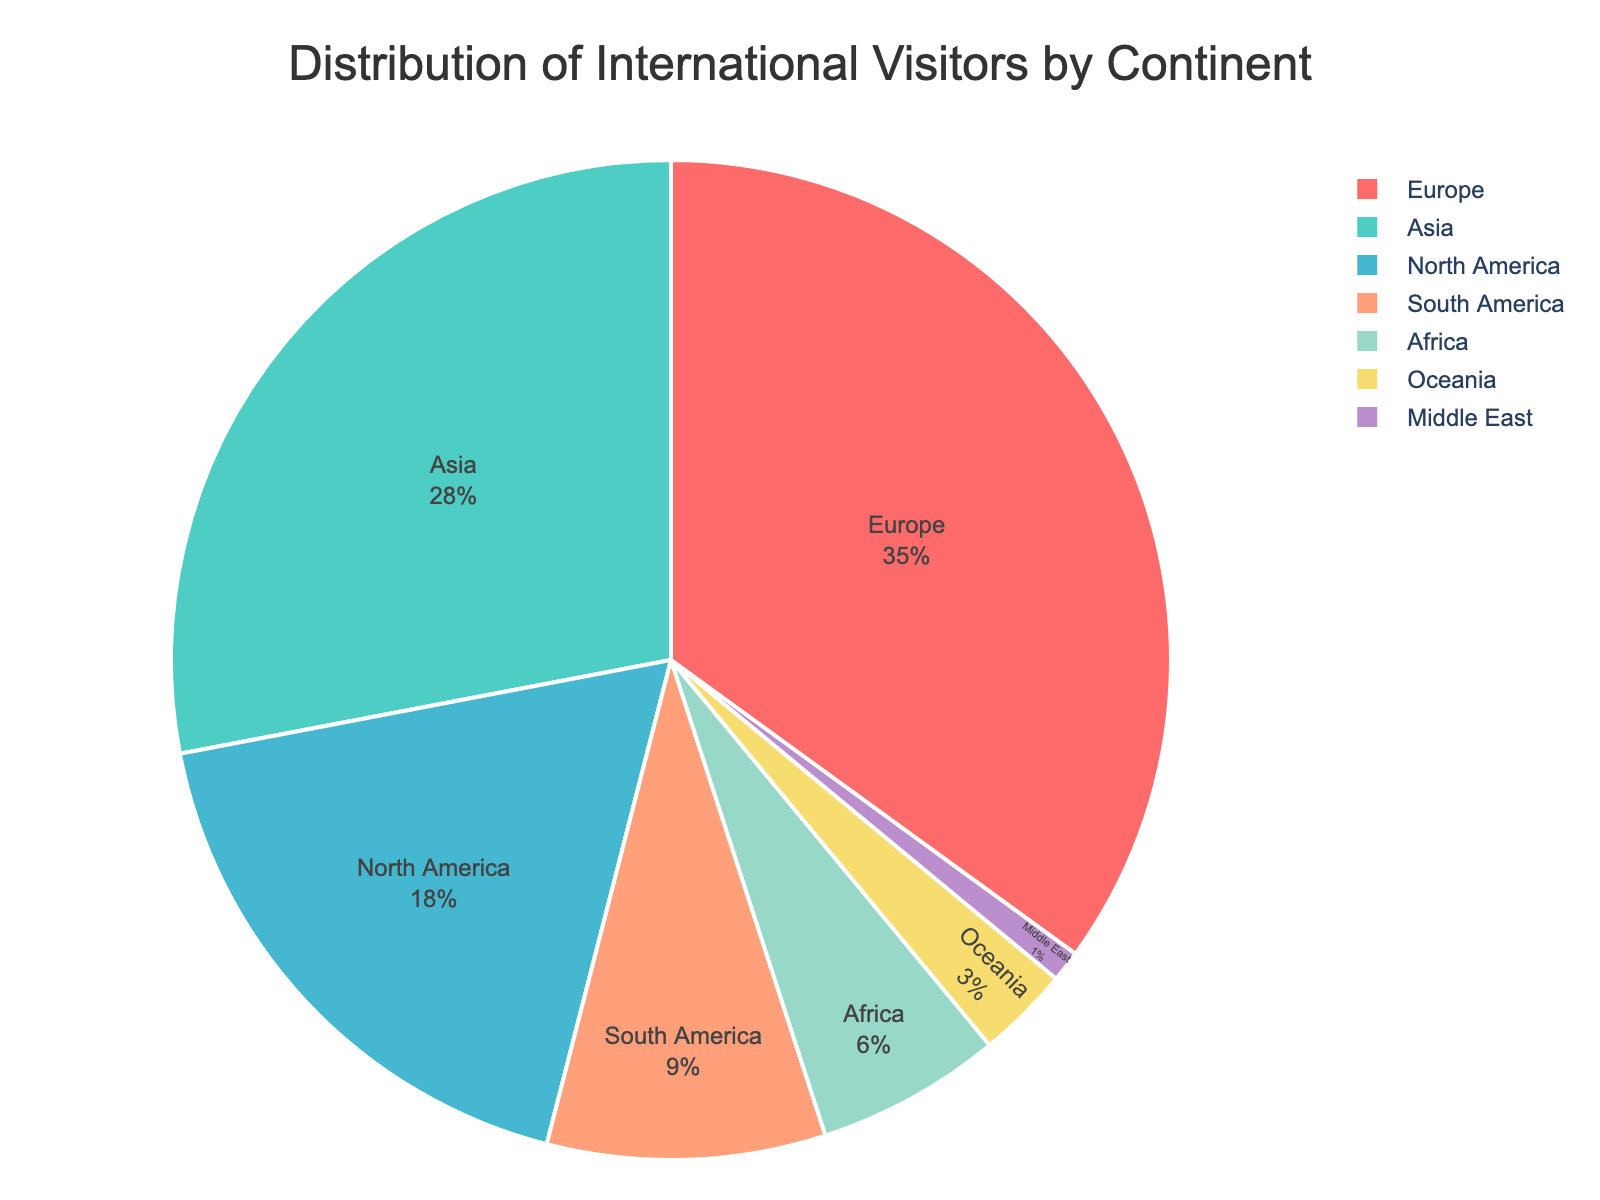Which continent contributes the highest percentage of visitors? The pie chart shows that Europe has the largest segment. The text inside the segment indicates that Europe contributes 35% of visitors.
Answer: Europe How many continents contribute less than 10% each? By examining the segments with percentages less than 10%, we find four continents: South America (9%), Africa (6%), Oceania (3%), and the Middle East (1%).
Answer: 4 What is the combined percentage of visitors from Asia and North America? The percentage of visitors from Asia is 28% and from North America is 18%. Summing these, 28% + 18% = 46%.
Answer: 46% Which continents have a difference in visitor percentages of less than 5%? The closest percentages are between Asia (28%) and Europe (35%), and between North America (18%) and South America (9%) among the smaller segments like Africa (6%) and Oceania (3%).
Answer: Asia and Europe; Africa and Oceania What's the percentage difference between the continent with the most visitors and the continent with the fewest visitors? Europe has the most visitors (35%) and the Middle East has the fewest (1%). The difference is 35% - 1% = 34%.
Answer: 34% If we were to combined the visitors from Africa and Oceania, would their total be more or less than those from North America? Africa's percentage is 6% and Oceania's is 3%. Their combined percentage is 6% + 3% = 9%, which is less than North America's 18%.
Answer: Less What visual attribute makes the segment for Africa stand out in the pie chart? The visual attribute is the color. Africa is represented by a distinct color which is separate from other continents.
Answer: Color Is the contribution of visitors from Asia greater or less than the sum of both South America and Oceania? South America contributes 9% and Oceania 3%. Their sum is 9% + 3% = 12%, which is less than Asia's 28%.
Answer: Greater 